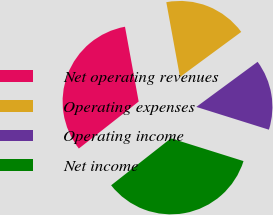Convert chart. <chart><loc_0><loc_0><loc_500><loc_500><pie_chart><fcel>Net operating revenues<fcel>Operating expenses<fcel>Operating income<fcel>Net income<nl><fcel>32.72%<fcel>17.78%<fcel>14.94%<fcel>34.56%<nl></chart> 